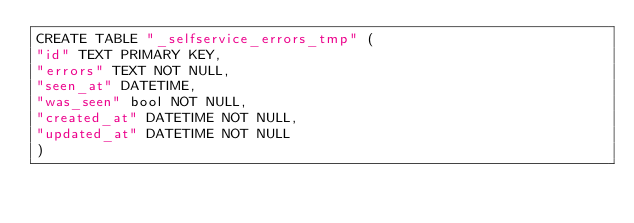Convert code to text. <code><loc_0><loc_0><loc_500><loc_500><_SQL_>CREATE TABLE "_selfservice_errors_tmp" (
"id" TEXT PRIMARY KEY,
"errors" TEXT NOT NULL,
"seen_at" DATETIME,
"was_seen" bool NOT NULL,
"created_at" DATETIME NOT NULL,
"updated_at" DATETIME NOT NULL
)</code> 